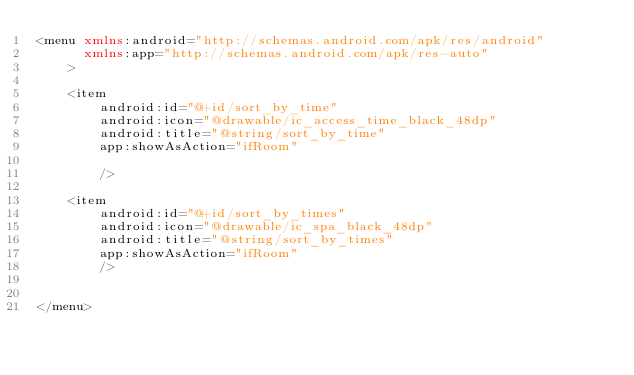Convert code to text. <code><loc_0><loc_0><loc_500><loc_500><_XML_><menu xmlns:android="http://schemas.android.com/apk/res/android"
      xmlns:app="http://schemas.android.com/apk/res-auto"
    >

    <item
        android:id="@+id/sort_by_time"
        android:icon="@drawable/ic_access_time_black_48dp"
        android:title="@string/sort_by_time"
        app:showAsAction="ifRoom"

        />

    <item
        android:id="@+id/sort_by_times"
        android:icon="@drawable/ic_spa_black_48dp"
        android:title="@string/sort_by_times"
        app:showAsAction="ifRoom"
        />


</menu></code> 